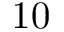Convert formula to latex. <formula><loc_0><loc_0><loc_500><loc_500>1 0</formula> 